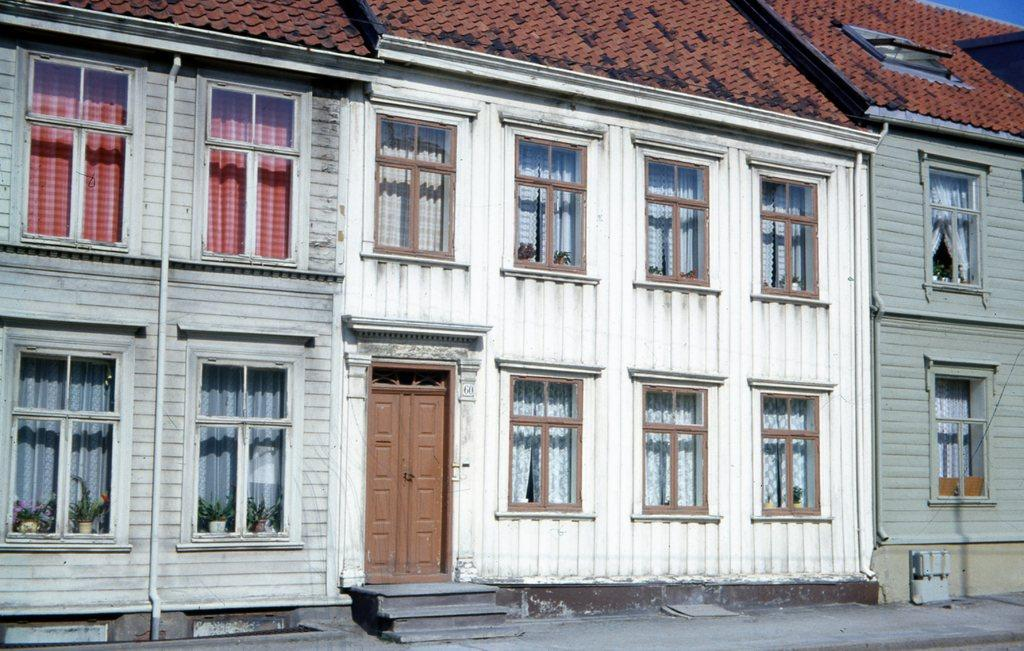What type of structure is in the image? There is a building in the image. What features can be seen on the building? The building has windows and doors. What can be seen through the windows? Curtains are visible through the windows, and there are pots with plants near the windows. Are there any architectural elements in the image? Yes, there are steps in the image. What type of channel can be seen running through the building in the image? There is no channel visible in the image; it features a building with windows, doors, curtains, pots with plants, and steps. 